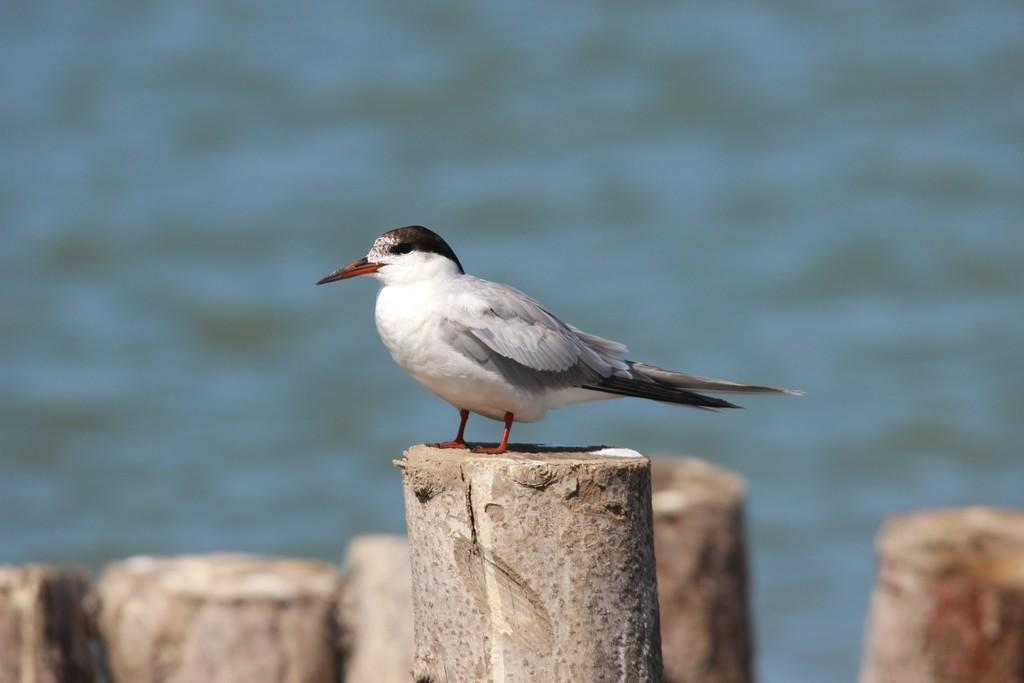What is the main subject in the front of the image? There is a bird in the front of the image. What type of material is present at the bottom of the image? There is some wood at the bottom of the image. How would you describe the background of the image? The background of the image is blurry. What type of song is the bird singing in the image? The image does not provide any information about the bird singing a song, so we cannot determine the type of song. 